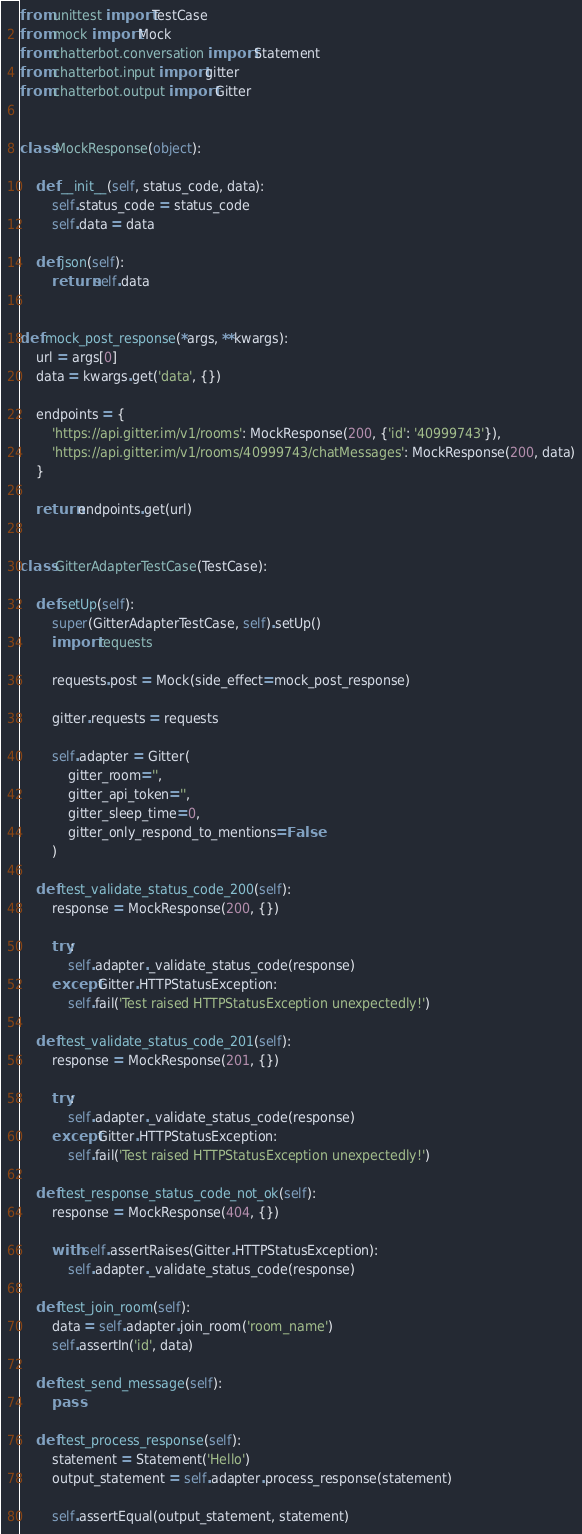Convert code to text. <code><loc_0><loc_0><loc_500><loc_500><_Python_>from unittest import TestCase
from mock import Mock
from chatterbot.conversation import Statement
from chatterbot.input import gitter
from chatterbot.output import Gitter


class MockResponse(object):

    def __init__(self, status_code, data):
        self.status_code = status_code
        self.data = data

    def json(self):
        return self.data


def mock_post_response(*args, **kwargs):
    url = args[0]
    data = kwargs.get('data', {})

    endpoints = {
        'https://api.gitter.im/v1/rooms': MockResponse(200, {'id': '40999743'}),
        'https://api.gitter.im/v1/rooms/40999743/chatMessages': MockResponse(200, data)
    }

    return endpoints.get(url)


class GitterAdapterTestCase(TestCase):

    def setUp(self):
        super(GitterAdapterTestCase, self).setUp()
        import requests

        requests.post = Mock(side_effect=mock_post_response)

        gitter.requests = requests

        self.adapter = Gitter(
            gitter_room='',
            gitter_api_token='',
            gitter_sleep_time=0,
            gitter_only_respond_to_mentions=False
        )

    def test_validate_status_code_200(self):
        response = MockResponse(200, {})

        try:
            self.adapter._validate_status_code(response)
        except Gitter.HTTPStatusException:
            self.fail('Test raised HTTPStatusException unexpectedly!')

    def test_validate_status_code_201(self):
        response = MockResponse(201, {})

        try:
            self.adapter._validate_status_code(response)
        except Gitter.HTTPStatusException:
            self.fail('Test raised HTTPStatusException unexpectedly!')

    def test_response_status_code_not_ok(self):
        response = MockResponse(404, {})

        with self.assertRaises(Gitter.HTTPStatusException):
            self.adapter._validate_status_code(response)

    def test_join_room(self):
        data = self.adapter.join_room('room_name')
        self.assertIn('id', data)

    def test_send_message(self):
        pass

    def test_process_response(self):
        statement = Statement('Hello')
        output_statement = self.adapter.process_response(statement)

        self.assertEqual(output_statement, statement)
</code> 